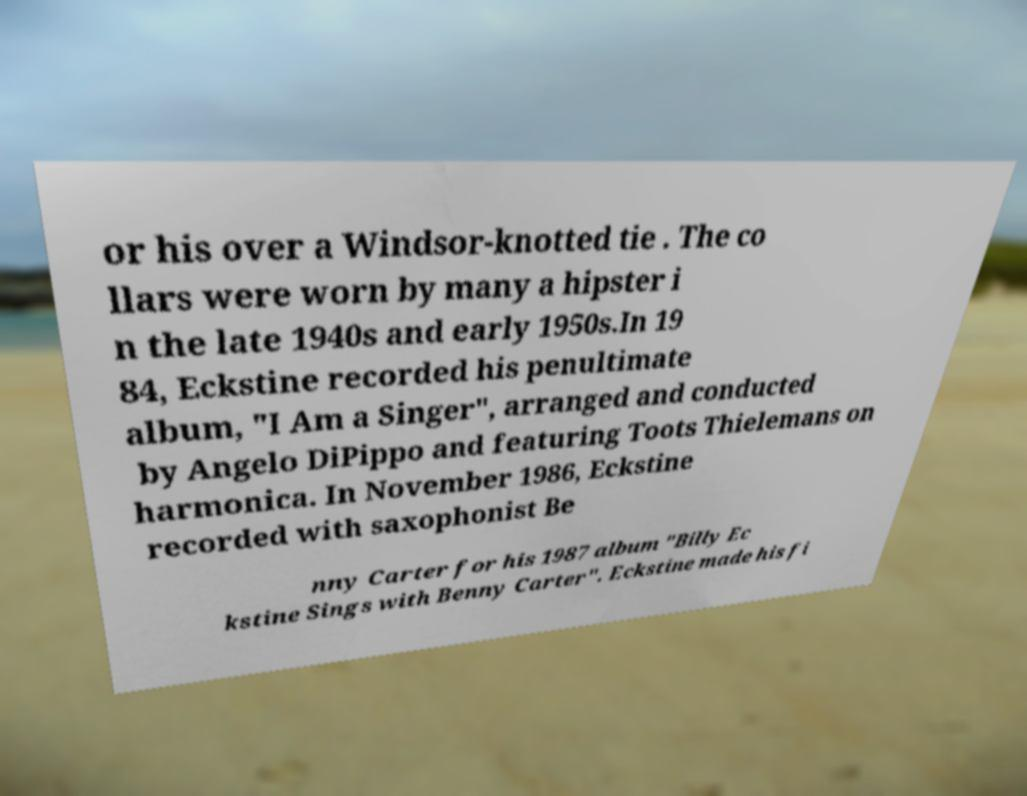There's text embedded in this image that I need extracted. Can you transcribe it verbatim? or his over a Windsor-knotted tie . The co llars were worn by many a hipster i n the late 1940s and early 1950s.In 19 84, Eckstine recorded his penultimate album, "I Am a Singer", arranged and conducted by Angelo DiPippo and featuring Toots Thielemans on harmonica. In November 1986, Eckstine recorded with saxophonist Be nny Carter for his 1987 album "Billy Ec kstine Sings with Benny Carter". Eckstine made his fi 